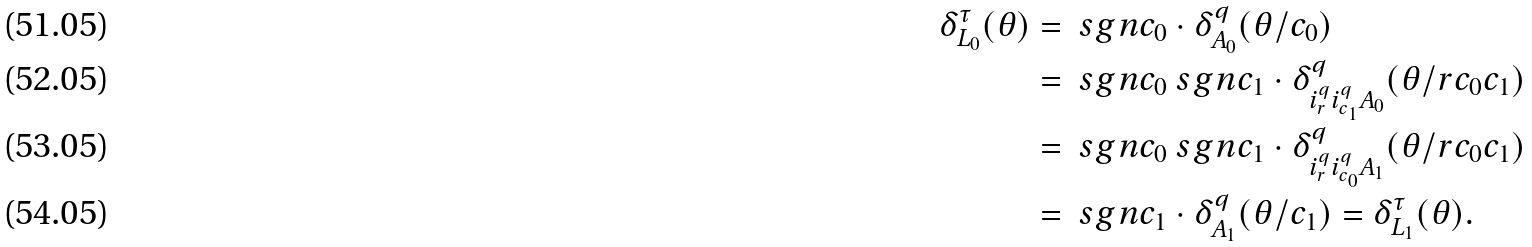<formula> <loc_0><loc_0><loc_500><loc_500>\delta ^ { \tau } _ { L _ { 0 } } ( \theta ) & = \ s g n c _ { 0 } \cdot \delta ^ { q } _ { A _ { 0 } } ( \theta / c _ { 0 } ) \\ & = \ s g n c _ { 0 } \ s g n c _ { 1 } \cdot \delta ^ { q } _ { i ^ { q } _ { r } i ^ { q } _ { c _ { 1 } } A _ { 0 } } ( \theta / r c _ { 0 } c _ { 1 } ) \\ & = \ s g n c _ { 0 } \ s g n c _ { 1 } \cdot \delta ^ { q } _ { i ^ { q } _ { r } i ^ { q } _ { c _ { 0 } } A _ { 1 } } ( \theta / r c _ { 0 } c _ { 1 } ) \\ & = \ s g n c _ { 1 } \cdot \delta ^ { q } _ { A _ { 1 } } ( \theta / c _ { 1 } ) = \delta ^ { \tau } _ { L _ { 1 } } ( \theta ) .</formula> 